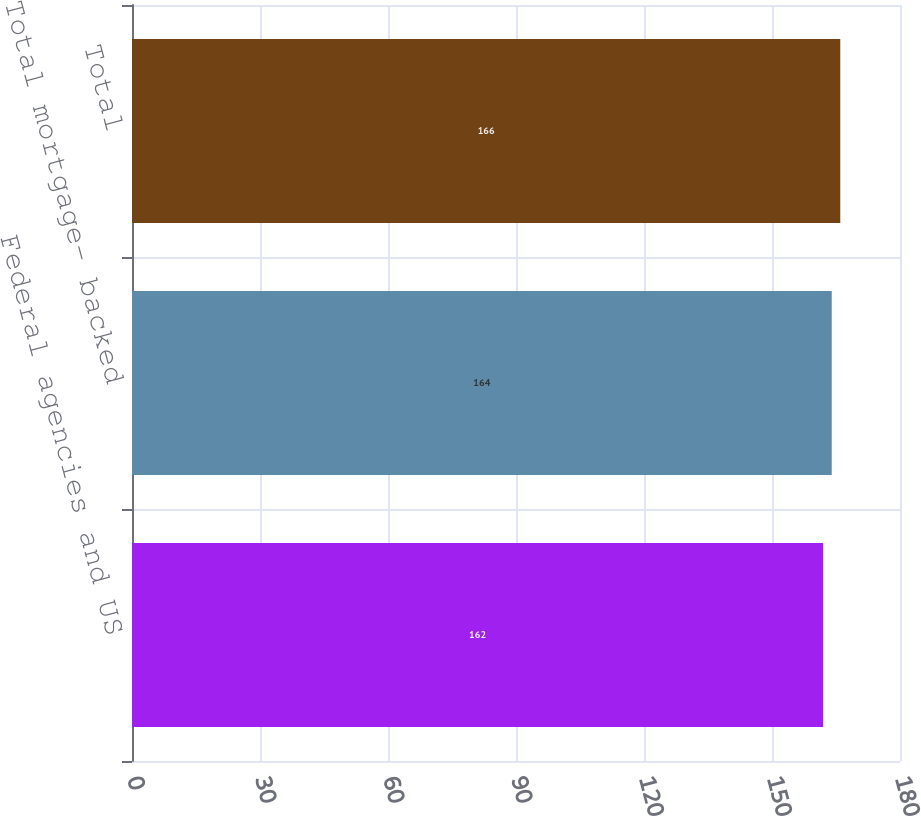<chart> <loc_0><loc_0><loc_500><loc_500><bar_chart><fcel>Federal agencies and US<fcel>Total mortgage- backed<fcel>Total<nl><fcel>162<fcel>164<fcel>166<nl></chart> 